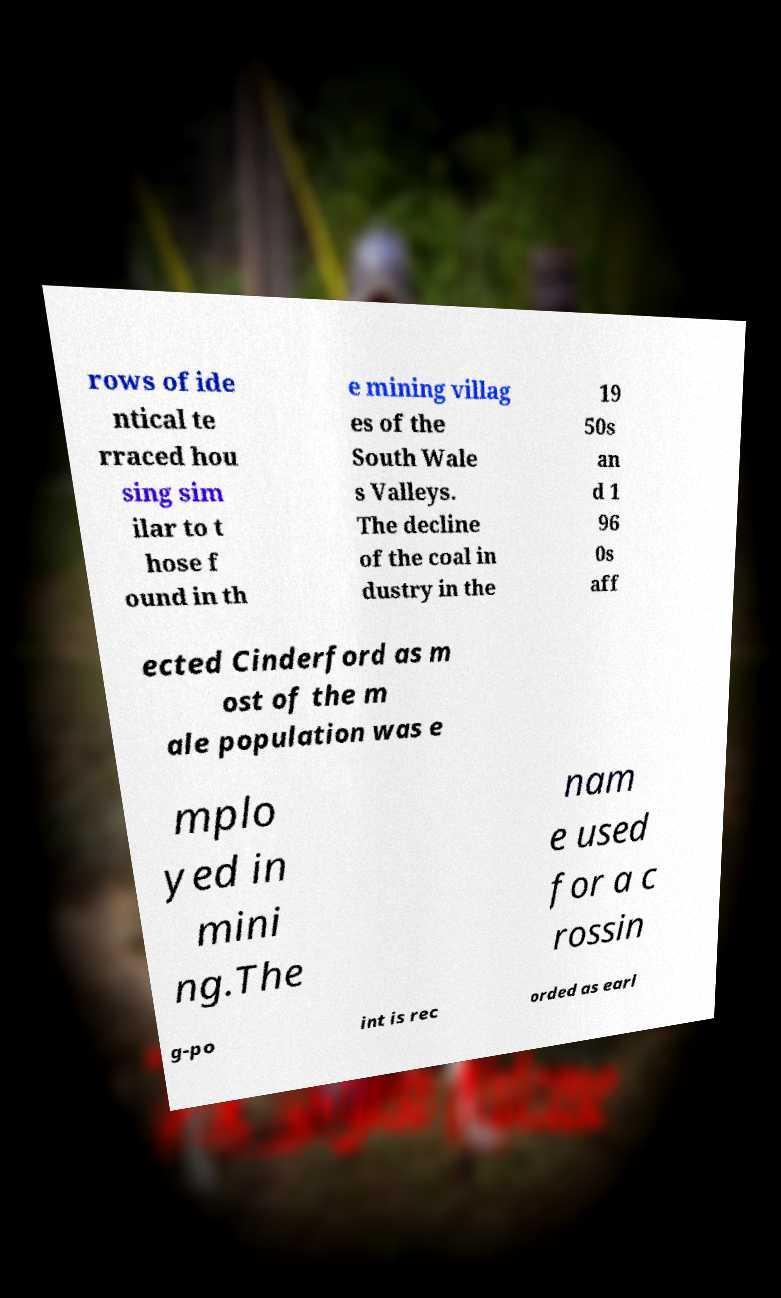Can you accurately transcribe the text from the provided image for me? rows of ide ntical te rraced hou sing sim ilar to t hose f ound in th e mining villag es of the South Wale s Valleys. The decline of the coal in dustry in the 19 50s an d 1 96 0s aff ected Cinderford as m ost of the m ale population was e mplo yed in mini ng.The nam e used for a c rossin g-po int is rec orded as earl 